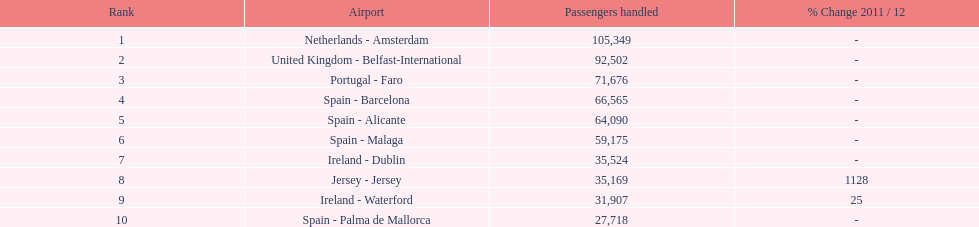Considering the top 10 busiest routes to and from london southend airport, what is the average volume of passengers processed? 58,967.5. 